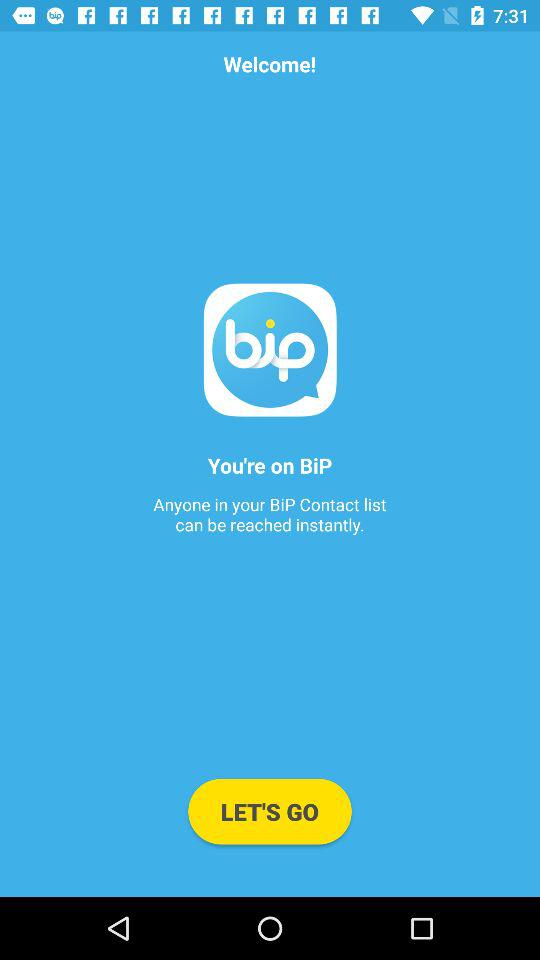What is the app name? The app name is "BiP". 